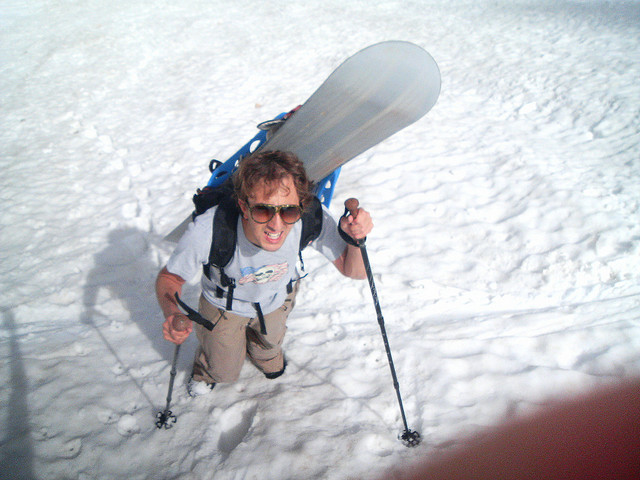<image>Is this man a professional snowboarder? I don't know if this man is a professional snowboarder. It's ambiguous. Is this man a professional snowboarder? I am not sure if this man is a professional snowboarder. It can be both yes or no. 